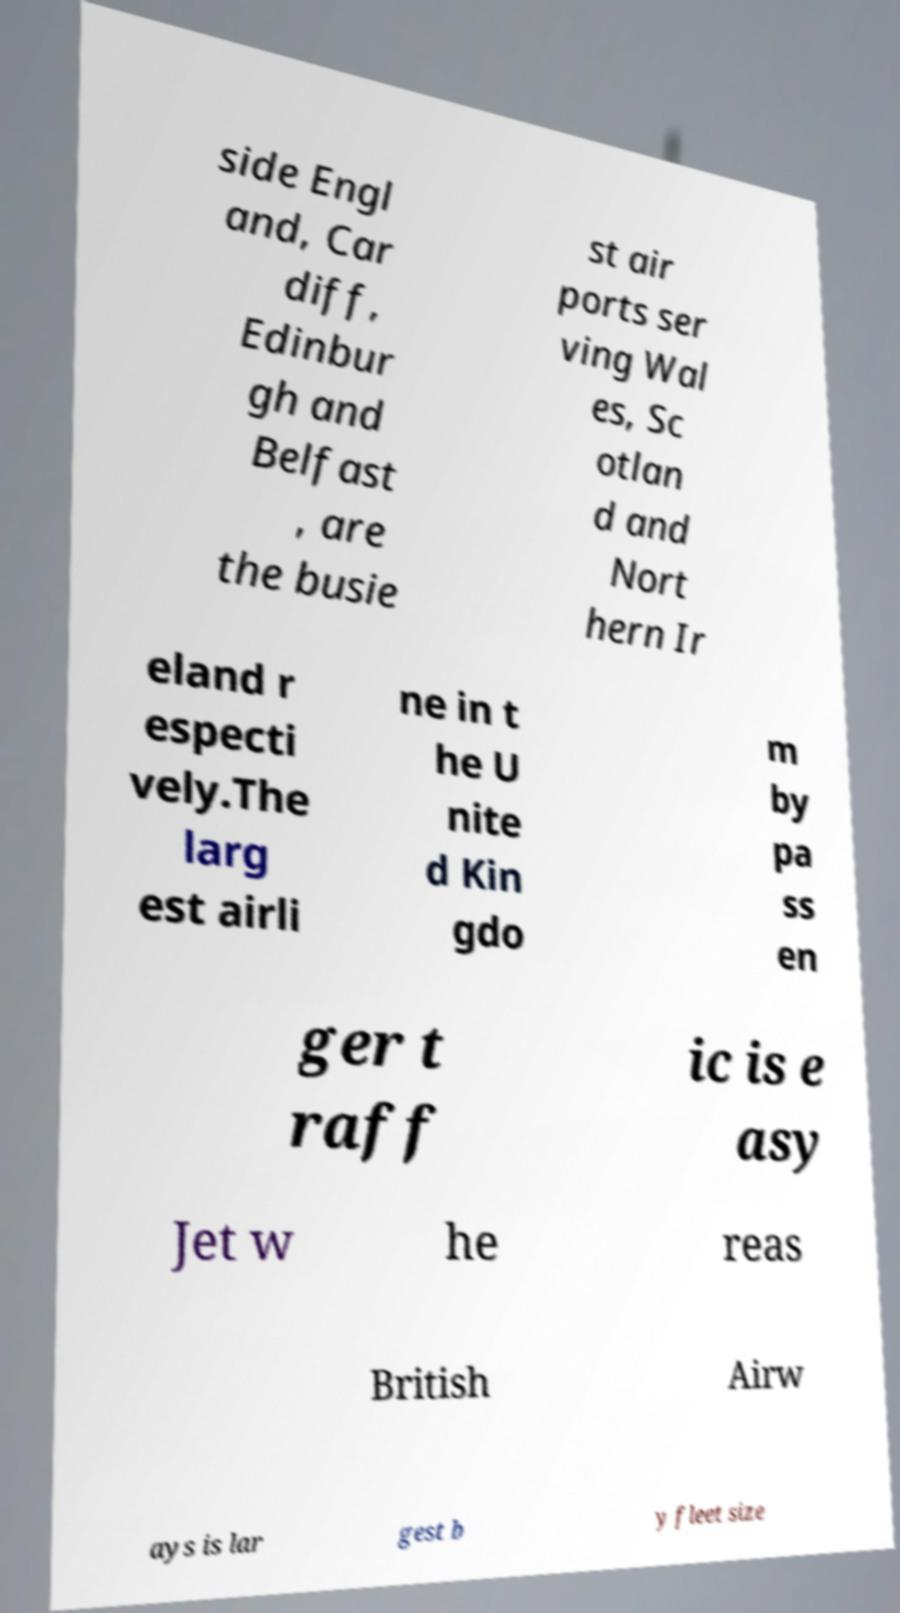I need the written content from this picture converted into text. Can you do that? side Engl and, Car diff, Edinbur gh and Belfast , are the busie st air ports ser ving Wal es, Sc otlan d and Nort hern Ir eland r especti vely.The larg est airli ne in t he U nite d Kin gdo m by pa ss en ger t raff ic is e asy Jet w he reas British Airw ays is lar gest b y fleet size 